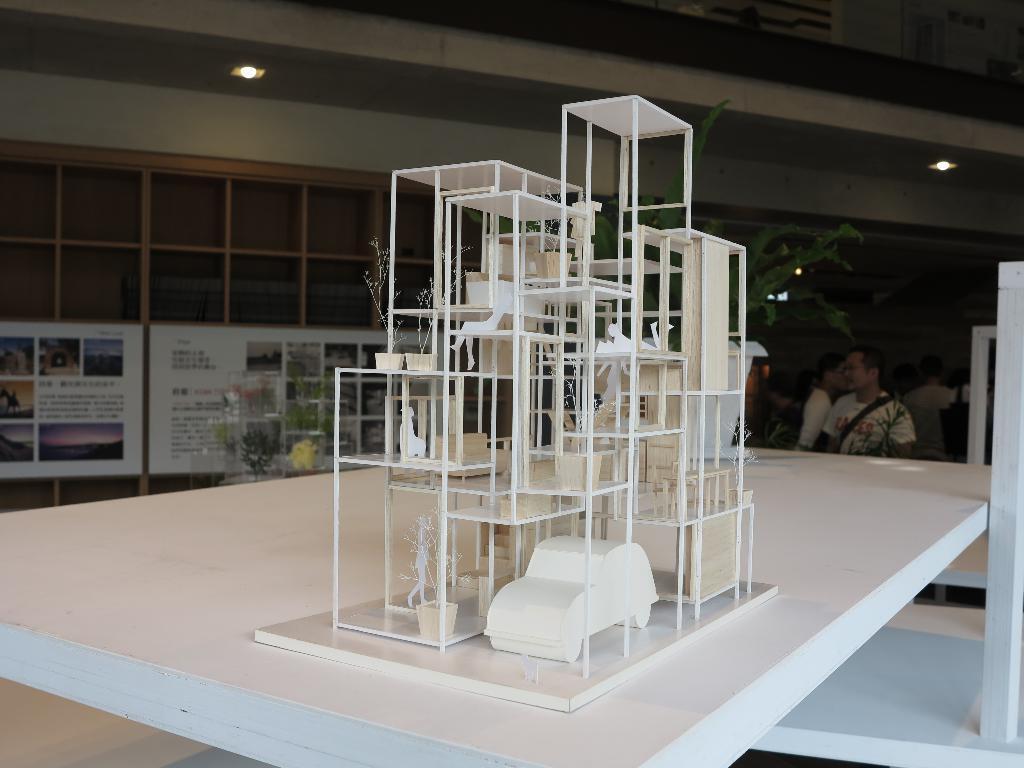Describe this image in one or two sentences. In this image I can see miniature of a house, at the back I can see few persons sitting, boards in white color and wall in cream color. I can also see a light. 